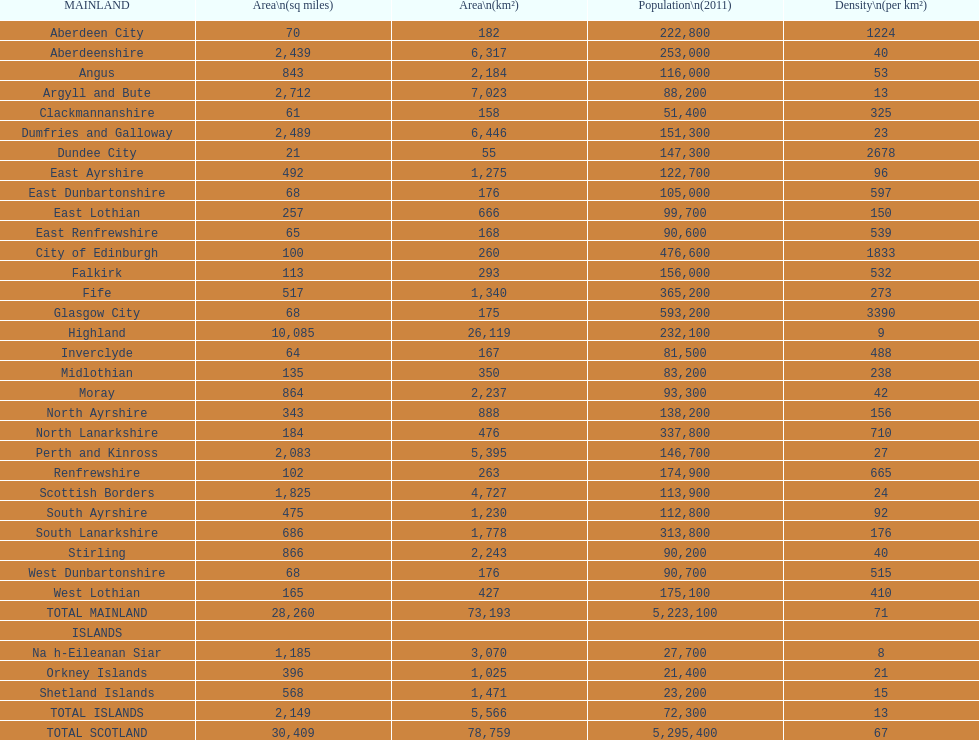What is the usual population density in mainland municipalities? 71. 